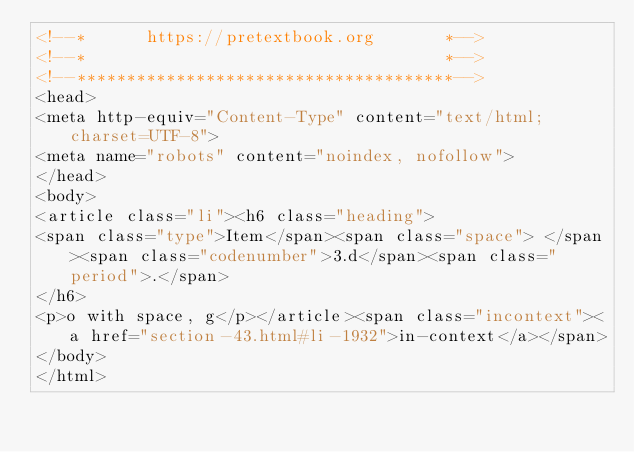<code> <loc_0><loc_0><loc_500><loc_500><_HTML_><!--*      https://pretextbook.org       *-->
<!--*                                    *-->
<!--**************************************-->
<head>
<meta http-equiv="Content-Type" content="text/html; charset=UTF-8">
<meta name="robots" content="noindex, nofollow">
</head>
<body>
<article class="li"><h6 class="heading">
<span class="type">Item</span><span class="space"> </span><span class="codenumber">3.d</span><span class="period">.</span>
</h6>
<p>o with space, g</p></article><span class="incontext"><a href="section-43.html#li-1932">in-context</a></span>
</body>
</html>
</code> 